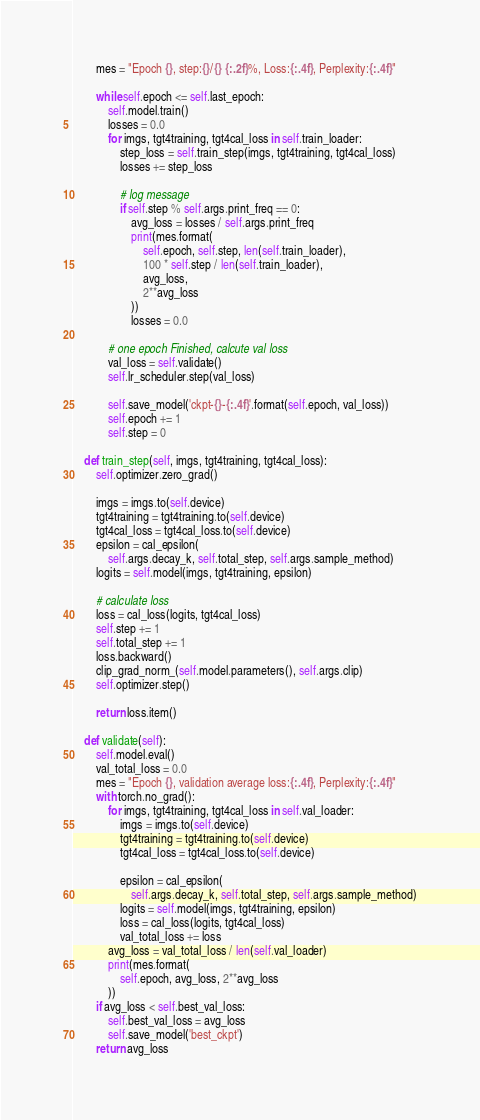<code> <loc_0><loc_0><loc_500><loc_500><_Python_>        mes = "Epoch {}, step:{}/{} {:.2f}%, Loss:{:.4f}, Perplexity:{:.4f}"

        while self.epoch <= self.last_epoch:
            self.model.train()
            losses = 0.0
            for imgs, tgt4training, tgt4cal_loss in self.train_loader:
                step_loss = self.train_step(imgs, tgt4training, tgt4cal_loss)
                losses += step_loss

                # log message
                if self.step % self.args.print_freq == 0:
                    avg_loss = losses / self.args.print_freq
                    print(mes.format(
                        self.epoch, self.step, len(self.train_loader),
                        100 * self.step / len(self.train_loader),
                        avg_loss,
                        2**avg_loss
                    ))
                    losses = 0.0

            # one epoch Finished, calcute val loss
            val_loss = self.validate()
            self.lr_scheduler.step(val_loss)

            self.save_model('ckpt-{}-{:.4f}'.format(self.epoch, val_loss))
            self.epoch += 1
            self.step = 0

    def train_step(self, imgs, tgt4training, tgt4cal_loss):
        self.optimizer.zero_grad()

        imgs = imgs.to(self.device)
        tgt4training = tgt4training.to(self.device)
        tgt4cal_loss = tgt4cal_loss.to(self.device)
        epsilon = cal_epsilon(
            self.args.decay_k, self.total_step, self.args.sample_method)
        logits = self.model(imgs, tgt4training, epsilon)

        # calculate loss
        loss = cal_loss(logits, tgt4cal_loss)
        self.step += 1
        self.total_step += 1
        loss.backward()
        clip_grad_norm_(self.model.parameters(), self.args.clip)
        self.optimizer.step()

        return loss.item()

    def validate(self):
        self.model.eval()
        val_total_loss = 0.0
        mes = "Epoch {}, validation average loss:{:.4f}, Perplexity:{:.4f}"
        with torch.no_grad():
            for imgs, tgt4training, tgt4cal_loss in self.val_loader:
                imgs = imgs.to(self.device)
                tgt4training = tgt4training.to(self.device)
                tgt4cal_loss = tgt4cal_loss.to(self.device)

                epsilon = cal_epsilon(
                    self.args.decay_k, self.total_step, self.args.sample_method)
                logits = self.model(imgs, tgt4training, epsilon)
                loss = cal_loss(logits, tgt4cal_loss)
                val_total_loss += loss
            avg_loss = val_total_loss / len(self.val_loader)
            print(mes.format(
                self.epoch, avg_loss, 2**avg_loss
            ))
        if avg_loss < self.best_val_loss:
            self.best_val_loss = avg_loss
            self.save_model('best_ckpt')
        return avg_loss
</code> 